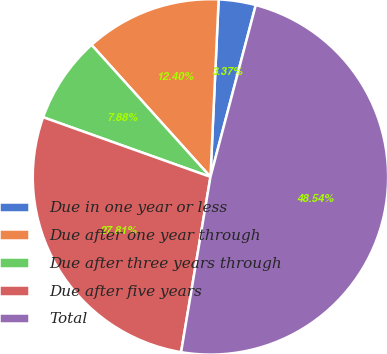Convert chart. <chart><loc_0><loc_0><loc_500><loc_500><pie_chart><fcel>Due in one year or less<fcel>Due after one year through<fcel>Due after three years through<fcel>Due after five years<fcel>Total<nl><fcel>3.37%<fcel>12.4%<fcel>7.88%<fcel>27.81%<fcel>48.54%<nl></chart> 